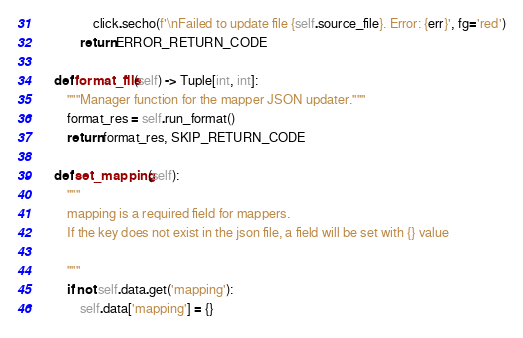Convert code to text. <code><loc_0><loc_0><loc_500><loc_500><_Python_>                click.secho(f'\nFailed to update file {self.source_file}. Error: {err}', fg='red')
            return ERROR_RETURN_CODE

    def format_file(self) -> Tuple[int, int]:
        """Manager function for the mapper JSON updater."""
        format_res = self.run_format()
        return format_res, SKIP_RETURN_CODE

    def set_mapping(self):
        """
        mapping is a required field for mappers.
        If the key does not exist in the json file, a field will be set with {} value

        """
        if not self.data.get('mapping'):
            self.data['mapping'] = {}
</code> 